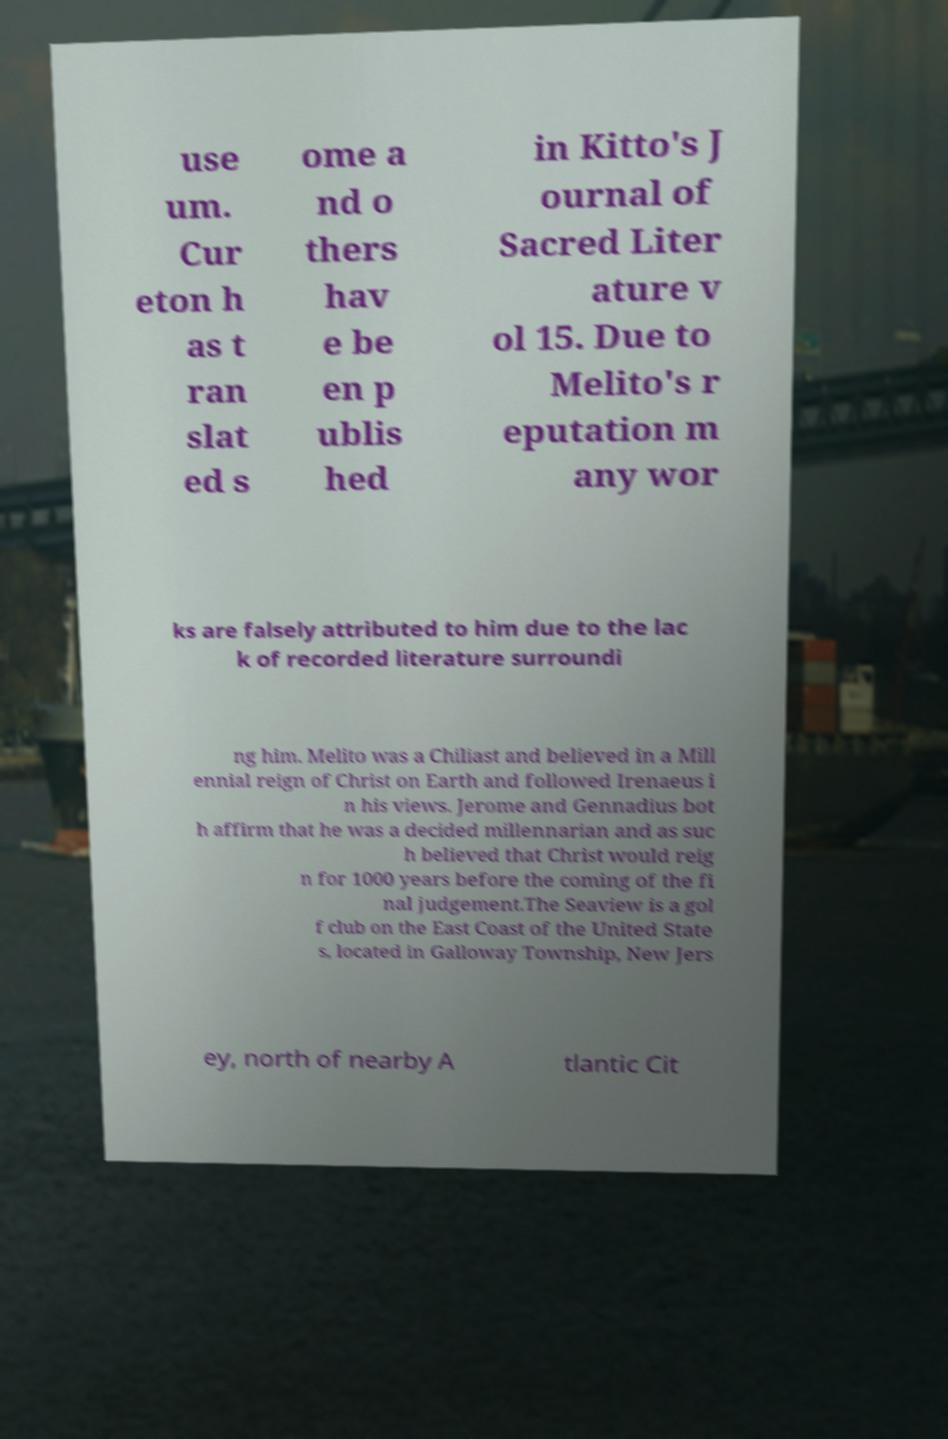Please read and relay the text visible in this image. What does it say? use um. Cur eton h as t ran slat ed s ome a nd o thers hav e be en p ublis hed in Kitto's J ournal of Sacred Liter ature v ol 15. Due to Melito's r eputation m any wor ks are falsely attributed to him due to the lac k of recorded literature surroundi ng him. Melito was a Chiliast and believed in a Mill ennial reign of Christ on Earth and followed Irenaeus i n his views. Jerome and Gennadius bot h affirm that he was a decided millennarian and as suc h believed that Christ would reig n for 1000 years before the coming of the fi nal judgement.The Seaview is a gol f club on the East Coast of the United State s, located in Galloway Township, New Jers ey, north of nearby A tlantic Cit 